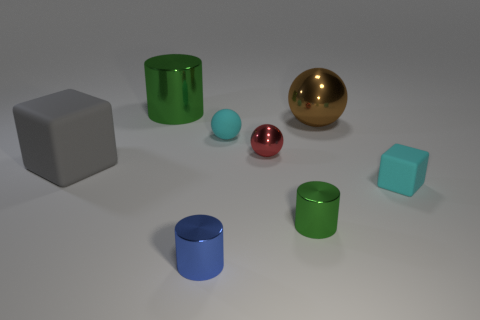There is a thing that is to the left of the blue cylinder and in front of the large brown sphere; what shape is it?
Offer a terse response. Cube. What number of tiny objects are shiny cylinders or purple rubber cubes?
Offer a terse response. 2. Are there an equal number of tiny balls that are left of the big block and blue things that are behind the large green cylinder?
Provide a succinct answer. Yes. What number of other objects are the same color as the large metallic sphere?
Your answer should be compact. 0. Is the number of cylinders that are to the left of the red object the same as the number of matte blocks?
Ensure brevity in your answer.  Yes. Does the blue cylinder have the same size as the red metal thing?
Your response must be concise. Yes. What is the small object that is behind the small cyan block and to the left of the small red metallic thing made of?
Give a very brief answer. Rubber. How many other metal things are the same shape as the small green metallic thing?
Give a very brief answer. 2. There is a green object behind the tiny green shiny cylinder; what material is it?
Provide a succinct answer. Metal. Are there fewer balls that are behind the red metallic thing than cylinders?
Make the answer very short. Yes. 